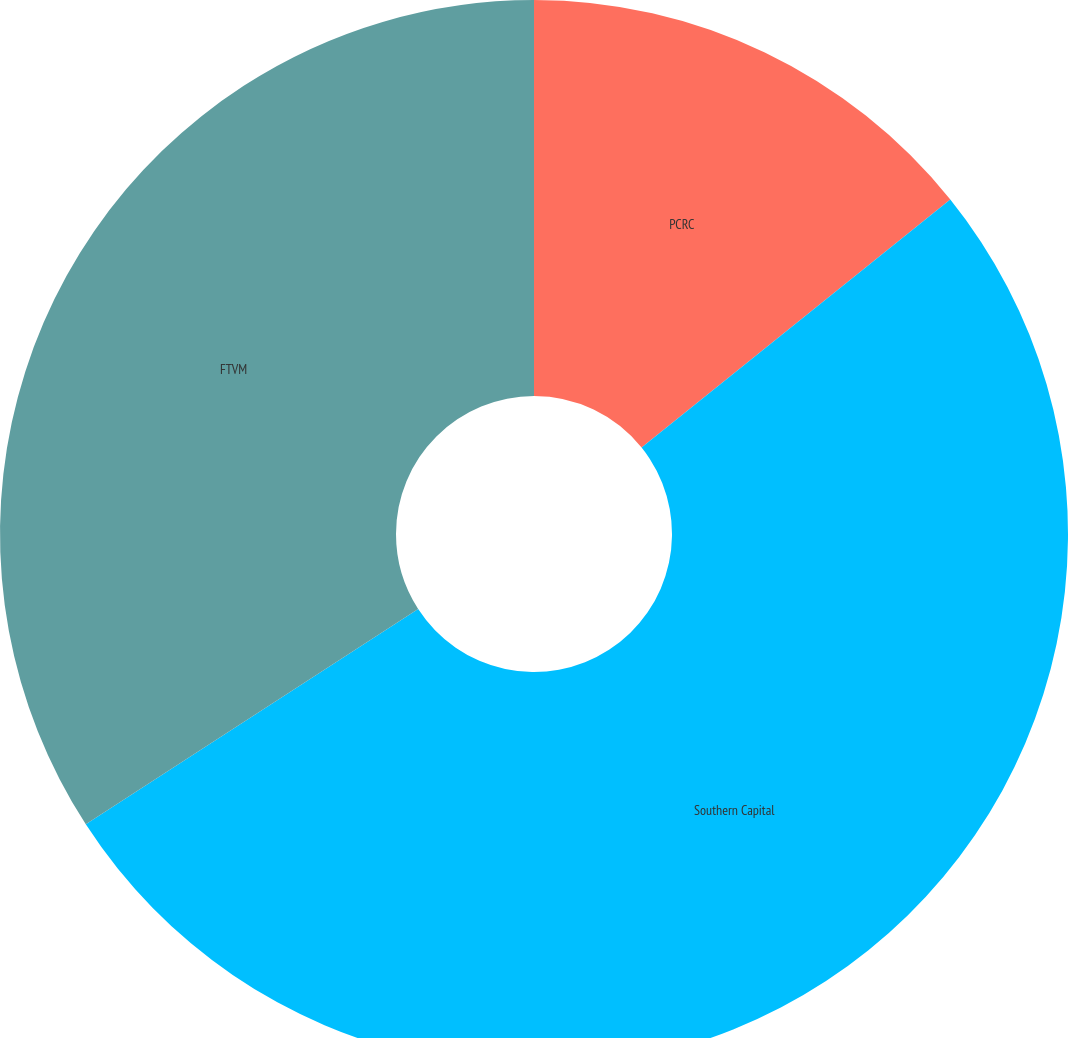<chart> <loc_0><loc_0><loc_500><loc_500><pie_chart><fcel>PCRC<fcel>Southern Capital<fcel>FTVM<nl><fcel>14.23%<fcel>51.63%<fcel>34.15%<nl></chart> 